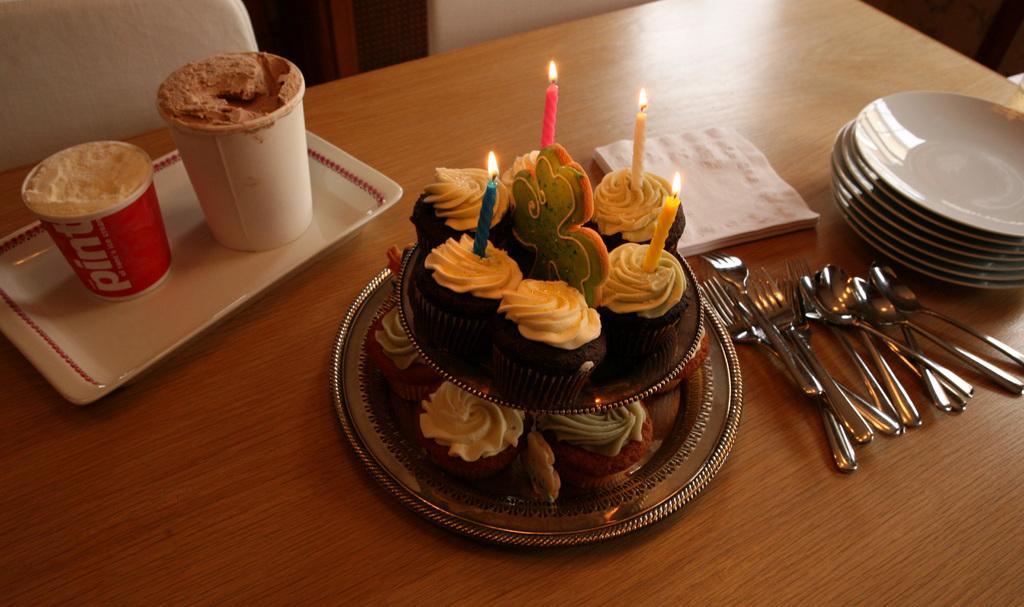Can you describe this image briefly? In this picture we can see a table on the table we have a cake candles and some tissues we have plates phones and one chair. 